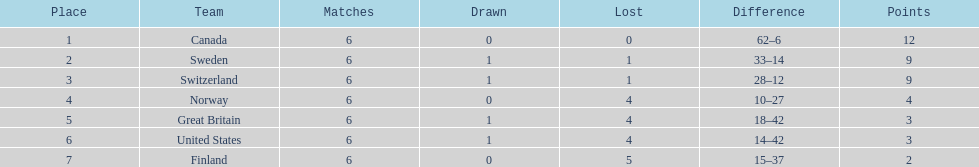What is the total number of teams to have 4 total wins? 2. 